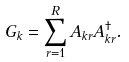Convert formula to latex. <formula><loc_0><loc_0><loc_500><loc_500>G _ { k } = \sum _ { r = 1 } ^ { R } A _ { k r } A ^ { \dagger } _ { k r } .</formula> 